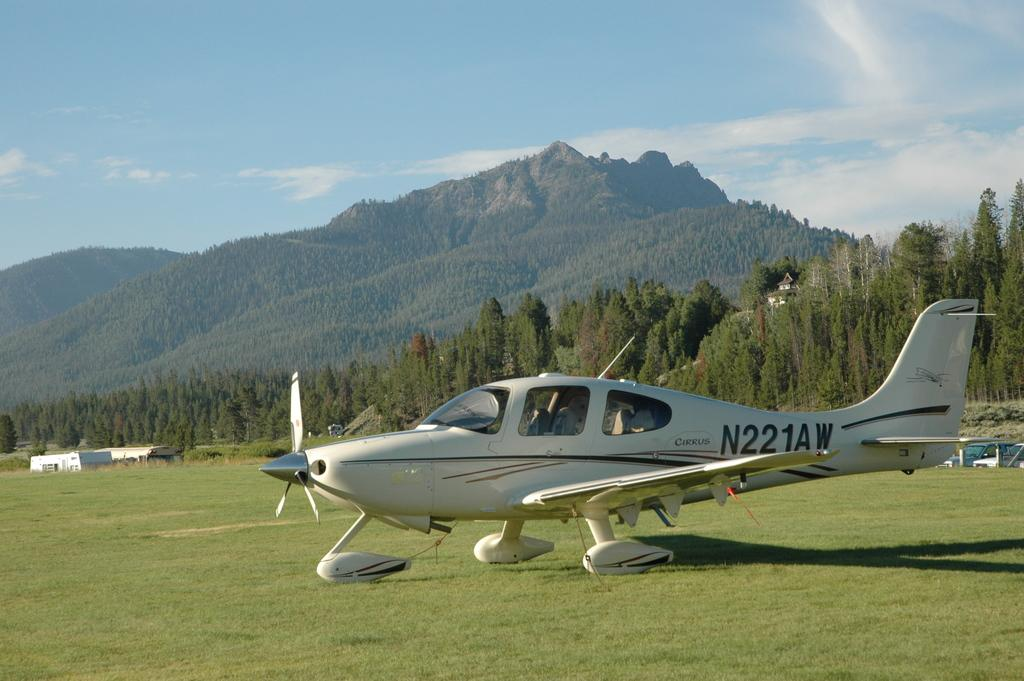What is the main subject in the foreground of the image? There is an airplane in the foreground of the image. What is the airplane's location in relation to the grass? The airplane is on the grass. What can be seen in the background of the image? There are trees, buildings, mountains, and the sky visible in the background of the image. Can you describe the sky in the image? The sky is visible in the background of the image, and there is a cloud present. What is the rate at which the dog is running in the image? There is no dog present in the image, so it is not possible to determine a running rate. 